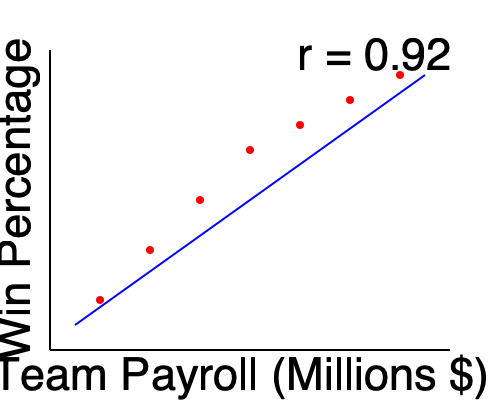As a sports historian analyzing the relationship between team payroll and win percentage in major leagues, what can you conclude about the strength and direction of the correlation based on the scatter plot and given correlation coefficient (r = 0.92)? To analyze the correlation between team payroll and win percentage, we need to consider both the scatter plot and the given correlation coefficient:

1. Visual inspection of the scatter plot:
   - The points form a clear upward trend from left to right.
   - There's a relatively tight clustering of points around an imaginary line.
   - This suggests a positive relationship between payroll and win percentage.

2. Correlation coefficient (r = 0.92):
   - The correlation coefficient ranges from -1 to +1.
   - A value of 0.92 is very close to +1.
   - The sign (+) indicates a positive correlation.
   - The magnitude (0.92) suggests a strong correlation.

3. Interpreting the correlation:
   - A correlation of 0.92 is considered very strong in statistical terms.
   - In the context of sports, this suggests that teams with higher payrolls tend to have higher win percentages.
   - However, correlation does not imply causation. Other factors may influence this relationship.

4. Historical context:
   - This strong correlation aligns with the "money ball" era in sports, where wealthier teams often had advantages in acquiring top talent.
   - It's important to note that exceptions exist, and efficient management can sometimes overcome payroll disparities.

5. Conclusion:
   - The data shows a strong, positive correlation between team payroll and win percentage in major sports leagues.
   - This relationship is consistent across the payroll range represented in the plot.
Answer: Strong positive correlation between team payroll and win percentage 